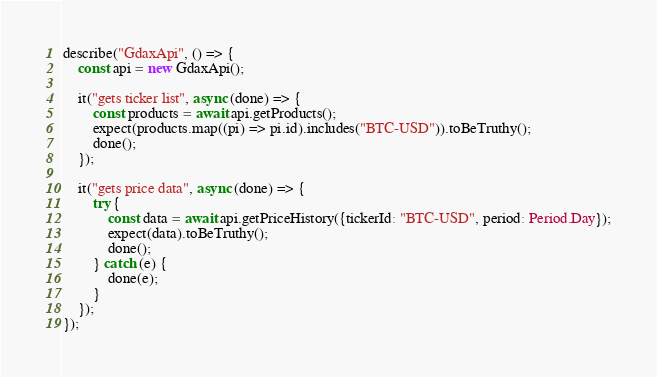<code> <loc_0><loc_0><loc_500><loc_500><_TypeScript_>
describe("GdaxApi", () => {
    const api = new GdaxApi();

    it("gets ticker list", async (done) => {
        const products = await api.getProducts();
        expect(products.map((pi) => pi.id).includes("BTC-USD")).toBeTruthy();
        done();
    });

    it("gets price data", async (done) => {
        try {
            const data = await api.getPriceHistory({tickerId: "BTC-USD", period: Period.Day});
            expect(data).toBeTruthy();
            done();
        } catch (e) {
            done(e);
        }
    });
});
</code> 